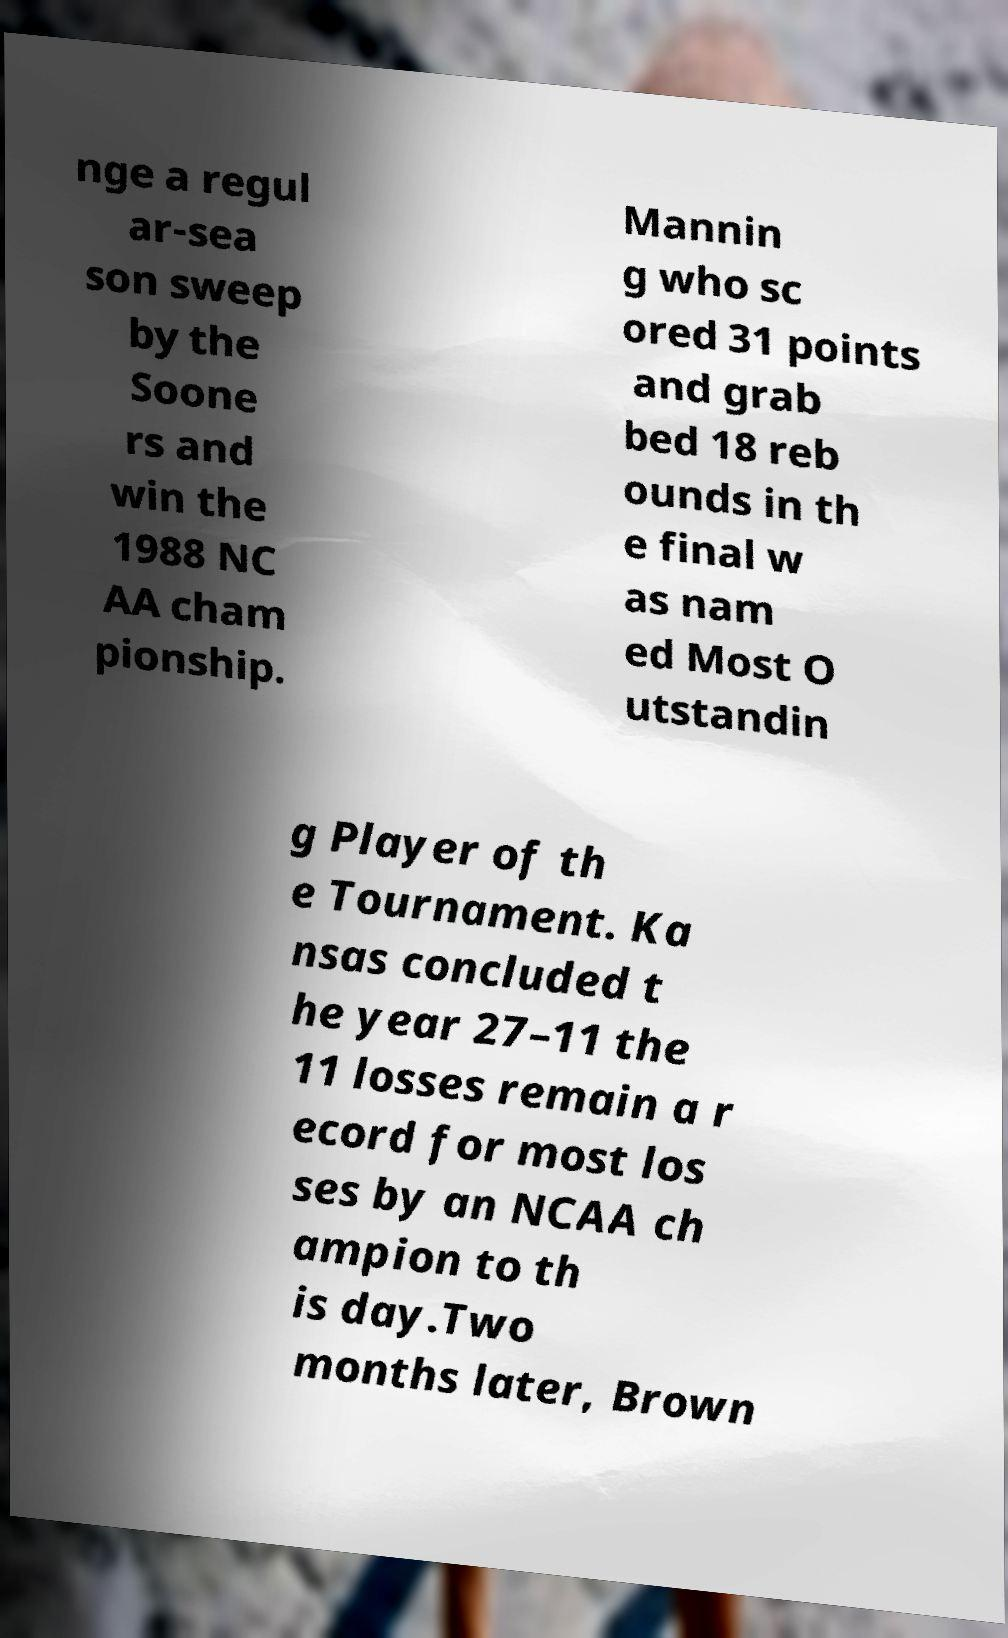Can you read and provide the text displayed in the image?This photo seems to have some interesting text. Can you extract and type it out for me? nge a regul ar-sea son sweep by the Soone rs and win the 1988 NC AA cham pionship. Mannin g who sc ored 31 points and grab bed 18 reb ounds in th e final w as nam ed Most O utstandin g Player of th e Tournament. Ka nsas concluded t he year 27–11 the 11 losses remain a r ecord for most los ses by an NCAA ch ampion to th is day.Two months later, Brown 